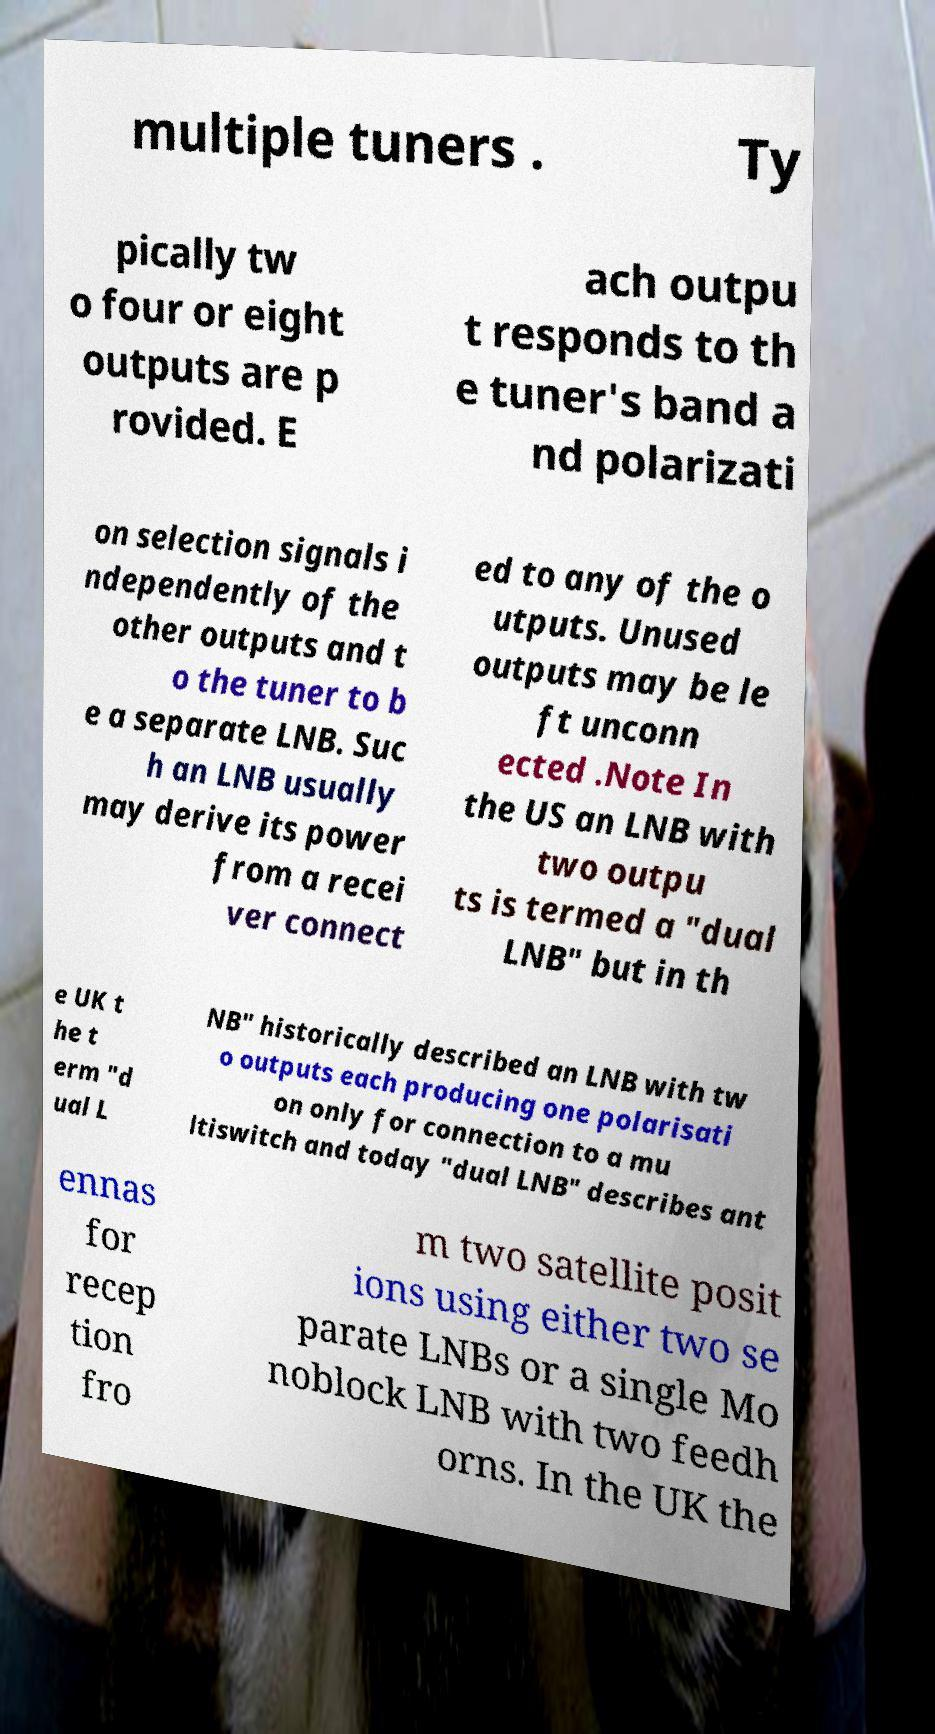What messages or text are displayed in this image? I need them in a readable, typed format. multiple tuners . Ty pically tw o four or eight outputs are p rovided. E ach outpu t responds to th e tuner's band a nd polarizati on selection signals i ndependently of the other outputs and t o the tuner to b e a separate LNB. Suc h an LNB usually may derive its power from a recei ver connect ed to any of the o utputs. Unused outputs may be le ft unconn ected .Note In the US an LNB with two outpu ts is termed a "dual LNB" but in th e UK t he t erm "d ual L NB" historically described an LNB with tw o outputs each producing one polarisati on only for connection to a mu ltiswitch and today "dual LNB" describes ant ennas for recep tion fro m two satellite posit ions using either two se parate LNBs or a single Mo noblock LNB with two feedh orns. In the UK the 